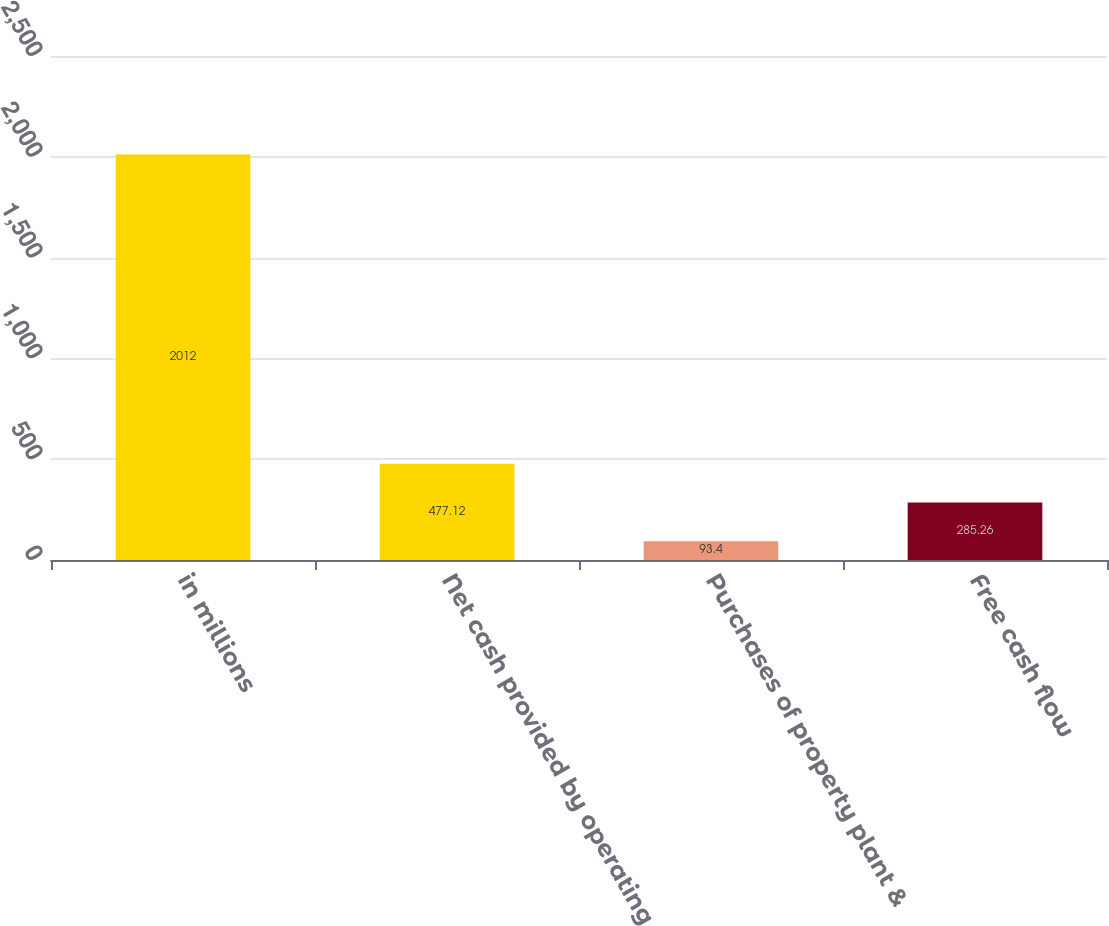Convert chart. <chart><loc_0><loc_0><loc_500><loc_500><bar_chart><fcel>in millions<fcel>Net cash provided by operating<fcel>Purchases of property plant &<fcel>Free cash flow<nl><fcel>2012<fcel>477.12<fcel>93.4<fcel>285.26<nl></chart> 